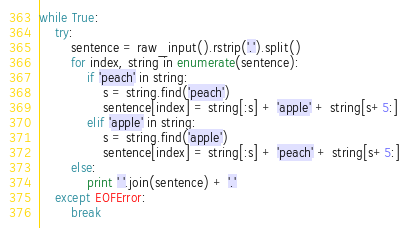<code> <loc_0><loc_0><loc_500><loc_500><_Python_>while True:
    try:
        sentence = raw_input().rstrip('.').split()
        for index, string in enumerate(sentence):
            if 'peach' in string:
                s = string.find('peach')
                sentence[index] = string[:s] + 'apple' + string[s+5:]
            elif 'apple' in string:
                s = string.find('apple')
                sentence[index] = string[:s] + 'peach' + string[s+5:]
        else:
            print ' '.join(sentence) + '.'
    except EOFError:
        break</code> 